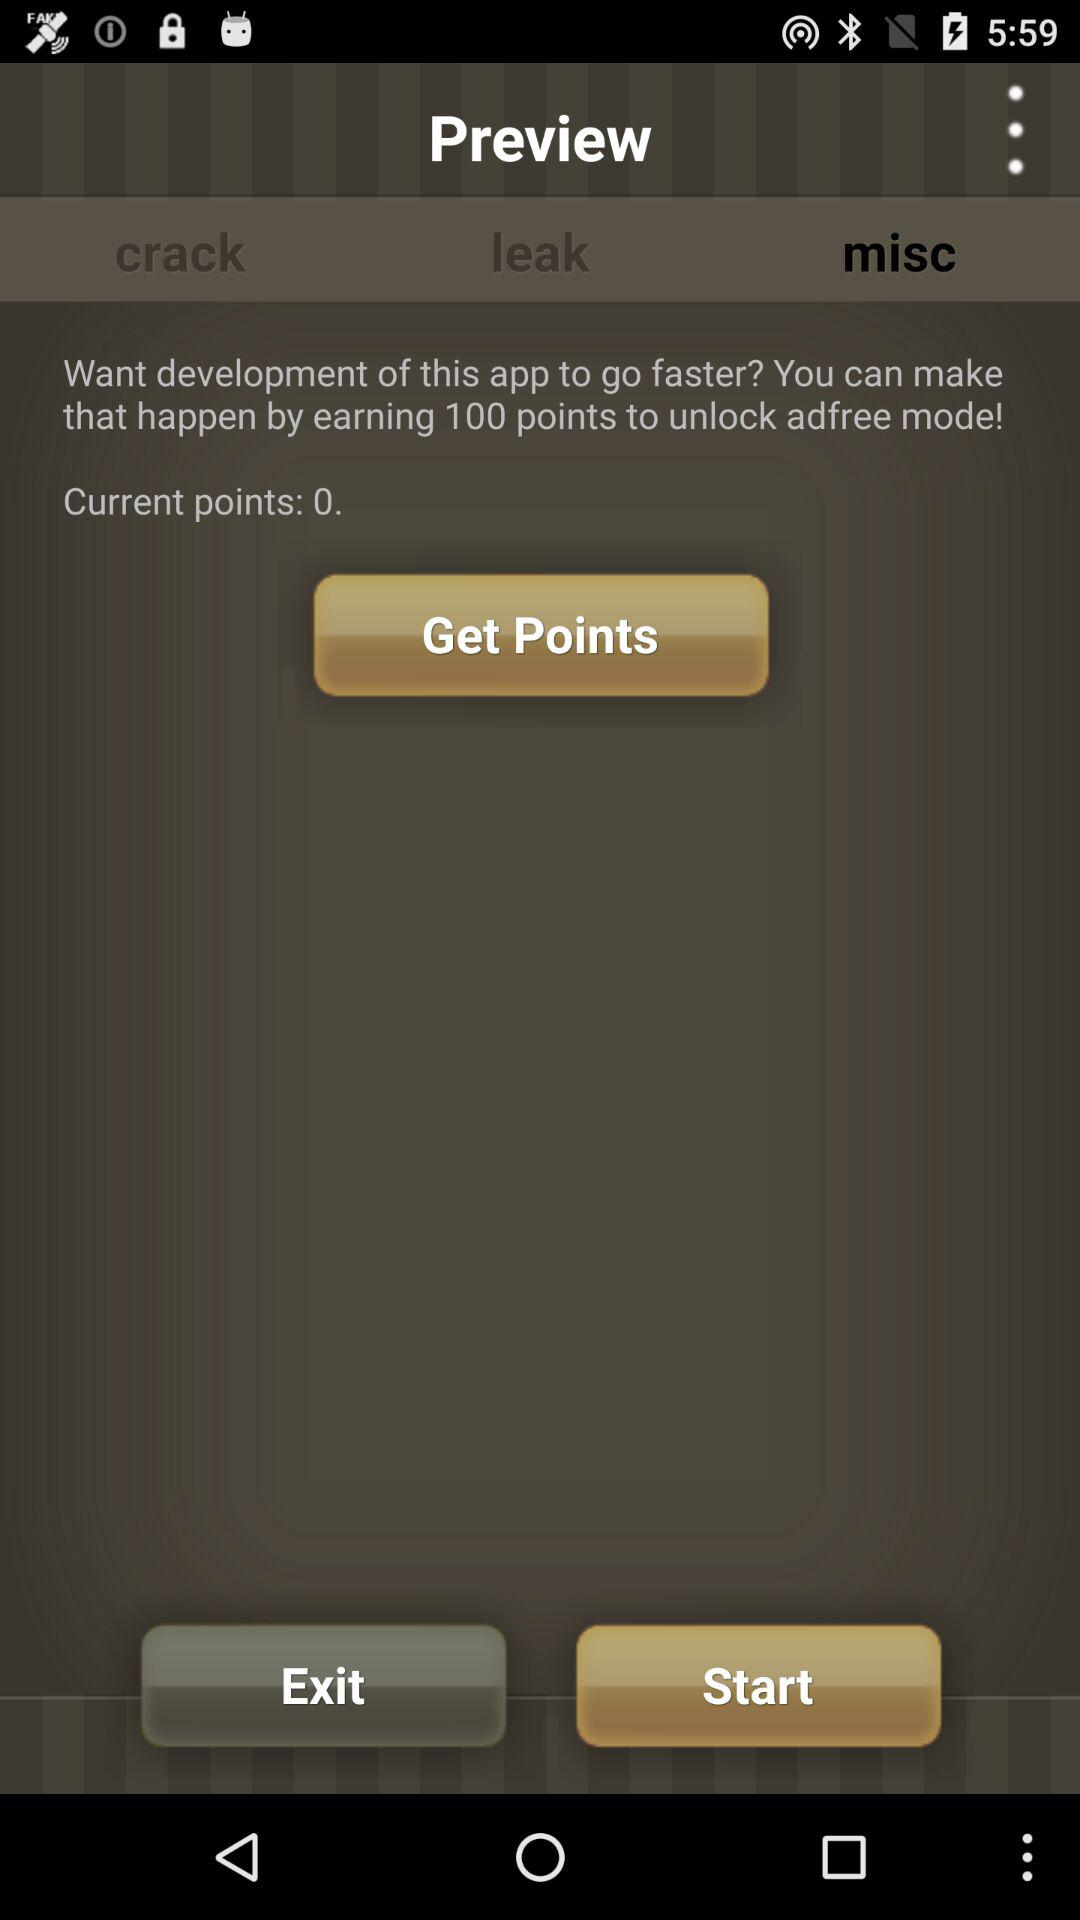What is the current point balance? The current point balance is 0. 